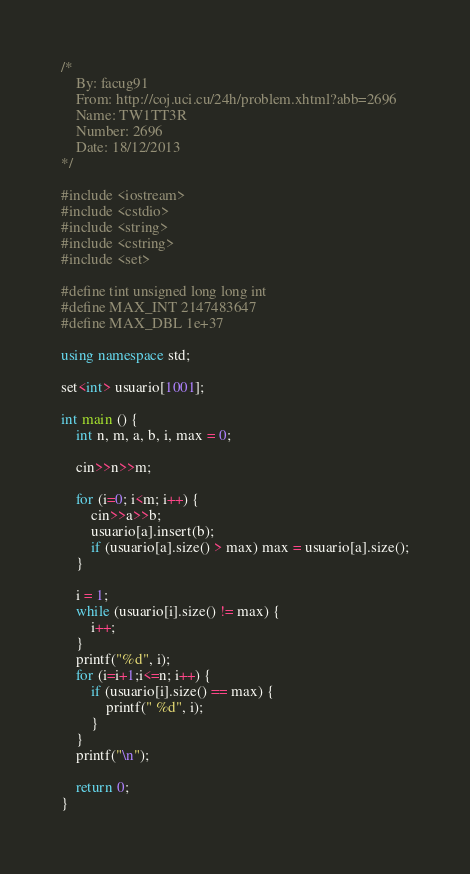Convert code to text. <code><loc_0><loc_0><loc_500><loc_500><_C++_>/*
	By: facug91
	From: http://coj.uci.cu/24h/problem.xhtml?abb=2696
	Name: TW1TT3R
	Number: 2696
	Date: 18/12/2013
*/

#include <iostream>
#include <cstdio>
#include <string>
#include <cstring>
#include <set>

#define tint unsigned long long int
#define MAX_INT 2147483647
#define MAX_DBL 1e+37

using namespace std;

set<int> usuario[1001];

int main () {
	int n, m, a, b, i, max = 0;
	
	cin>>n>>m;
	
	for (i=0; i<m; i++) {
		cin>>a>>b;
		usuario[a].insert(b);
		if (usuario[a].size() > max) max = usuario[a].size();
	}
	
	i = 1;
	while (usuario[i].size() != max) {
		i++;
	}
	printf("%d", i);
	for (i=i+1;i<=n; i++) {
		if (usuario[i].size() == max) {
			printf(" %d", i);
		}
	}
	printf("\n");
	
	return 0;
}
</code> 